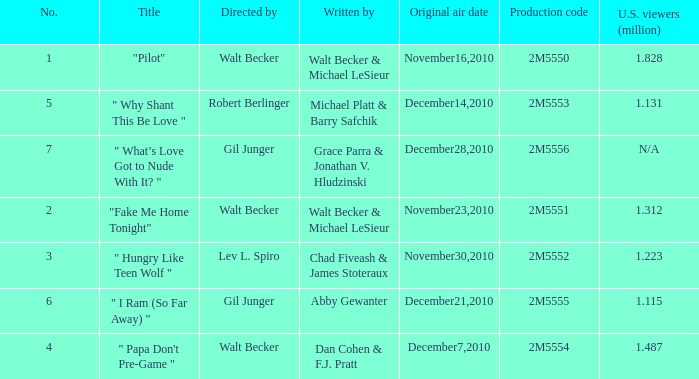Which episode number saw 1.312 million U.S. Wviewers? 2.0. 